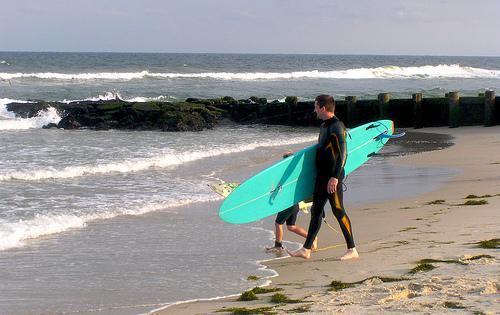How many people are pictured?
Give a very brief answer. 2. How many adults are pictured?
Give a very brief answer. 1. 